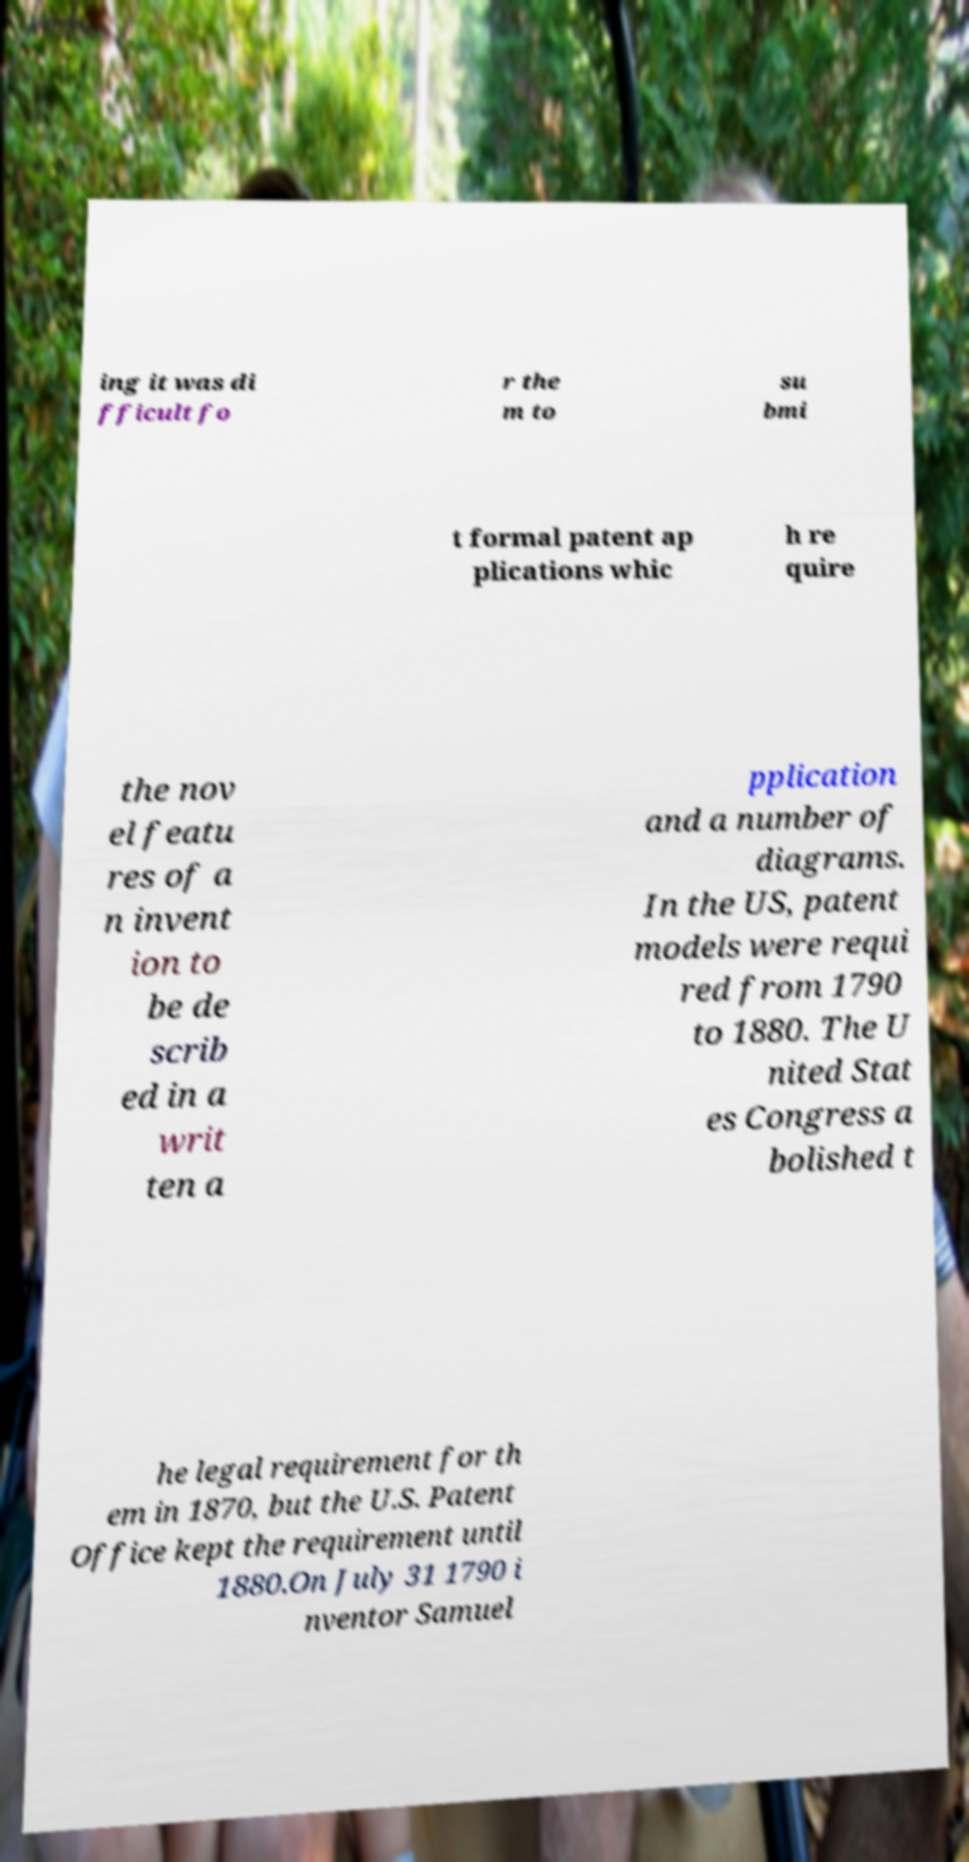I need the written content from this picture converted into text. Can you do that? ing it was di fficult fo r the m to su bmi t formal patent ap plications whic h re quire the nov el featu res of a n invent ion to be de scrib ed in a writ ten a pplication and a number of diagrams. In the US, patent models were requi red from 1790 to 1880. The U nited Stat es Congress a bolished t he legal requirement for th em in 1870, but the U.S. Patent Office kept the requirement until 1880.On July 31 1790 i nventor Samuel 